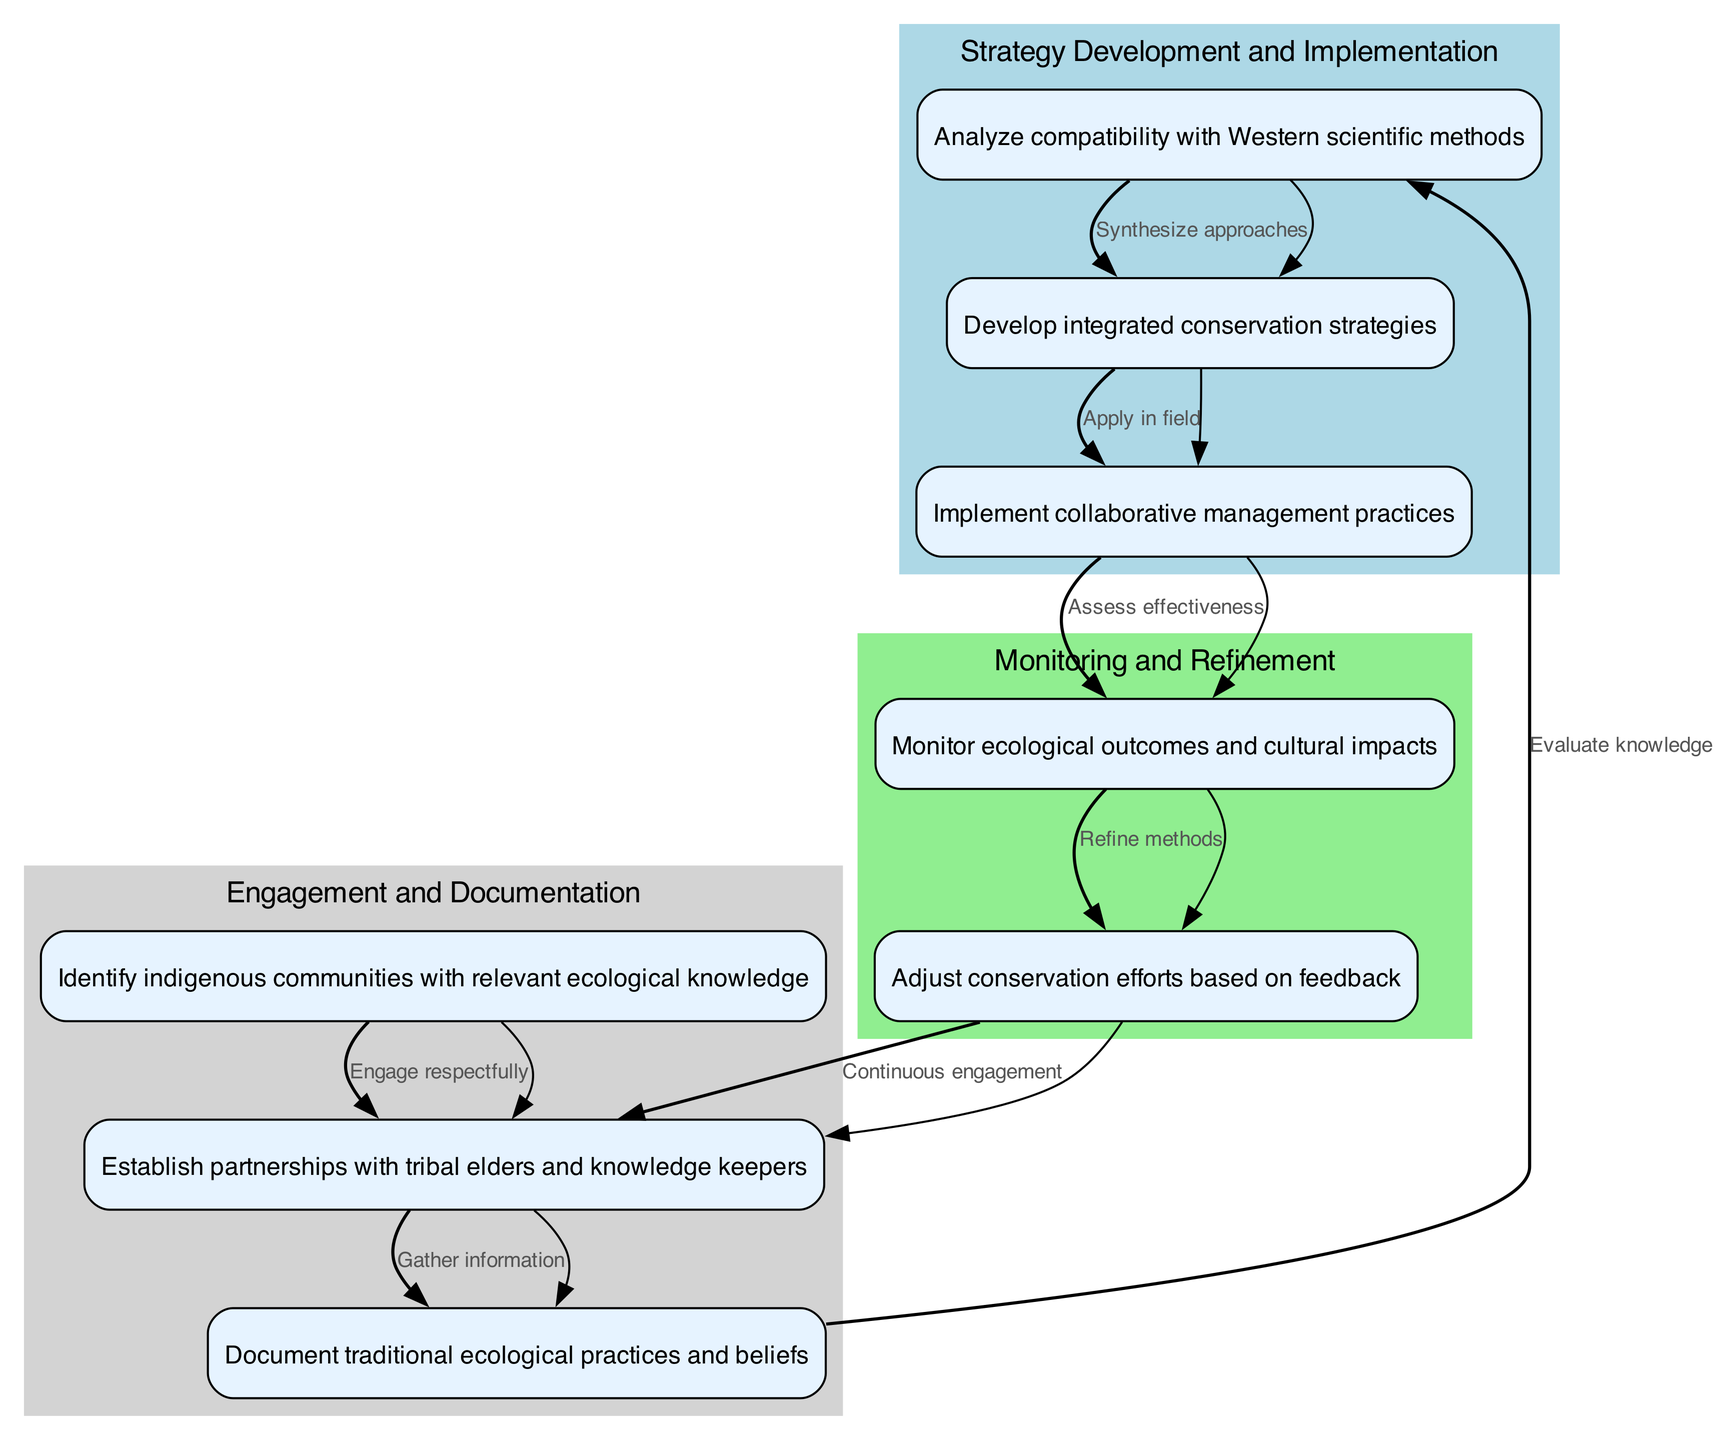What is the first node in the diagram? The first node in the diagram is "Identify indigenous communities with relevant ecological knowledge," as it is at the top and initiates the pathway.
Answer: Identify indigenous communities with relevant ecological knowledge How many edges are there in total? To find the number of edges, one can count the connections between nodes in the diagram. There are eight edges that connect the nodes.
Answer: 8 What comes directly after "Establish partnerships with tribal elders and knowledge keepers"? Following "Establish partnerships with tribal elders and knowledge keepers," the next action is "Document traditional ecological practices and beliefs," which is directly connected by an edge.
Answer: Document traditional ecological practices and beliefs Which node evaluates the compatibility with Western scientific methods? The node that evaluates the compatibility with Western scientific methods is "Analyze compatibility with Western scientific methods," which is after documenting traditional ecological practices.
Answer: Analyze compatibility with Western scientific methods What is the last node in the diagram? The last node in the diagram is "Adjust conservation efforts based on feedback," as it is the final step in the pathway before looping back to the second node.
Answer: Adjust conservation efforts based on feedback How does the process cycle back to engagement? The process cycles back to engagement through the edge "Continuous engagement," which connects the last node to the second node, indicating ongoing collaboration with tribal elders.
Answer: Continuous engagement What happens after "Monitor ecological outcomes and cultural impacts"? After "Monitor ecological outcomes and cultural impacts," the next step is "Adjust conservation efforts based on feedback," indicating a responsive action to the monitored outcomes.
Answer: Adjust conservation efforts based on feedback Which two clusters are present in the diagram? The two clusters present in the diagram are "Engagement and Documentation," and "Strategy Development and Implementation," as visual groupings of related nodes.
Answer: Engagement and Documentation; Strategy Development and Implementation What is the primary focus of the node under 'Monitoring and Refinement'? The primary focus of the node under 'Monitoring and Refinement' is "Monitor ecological outcomes and cultural impacts," which indicates a focus on assessing the results of conservation initiatives.
Answer: Monitor ecological outcomes and cultural impacts 